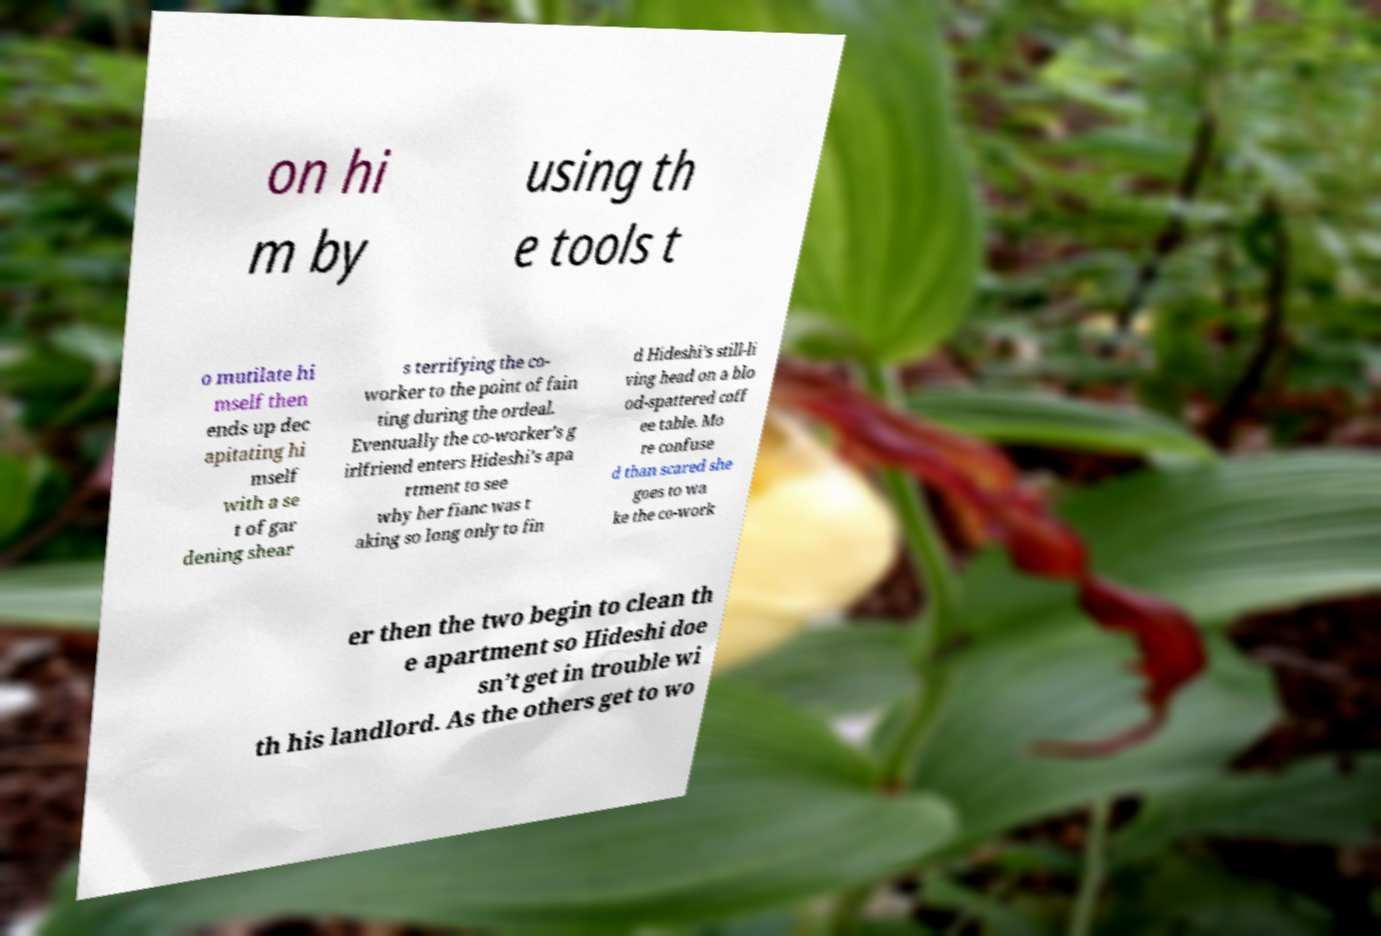There's text embedded in this image that I need extracted. Can you transcribe it verbatim? on hi m by using th e tools t o mutilate hi mself then ends up dec apitating hi mself with a se t of gar dening shear s terrifying the co- worker to the point of fain ting during the ordeal. Eventually the co-worker’s g irlfriend enters Hideshi’s apa rtment to see why her fianc was t aking so long only to fin d Hideshi’s still-li ving head on a blo od-spattered coff ee table. Mo re confuse d than scared she goes to wa ke the co-work er then the two begin to clean th e apartment so Hideshi doe sn’t get in trouble wi th his landlord. As the others get to wo 